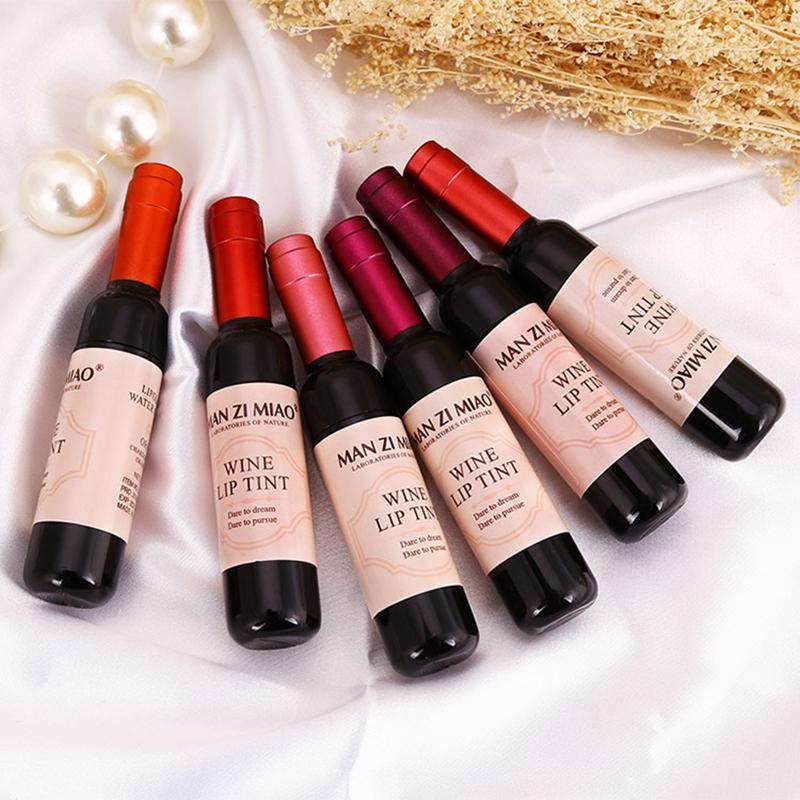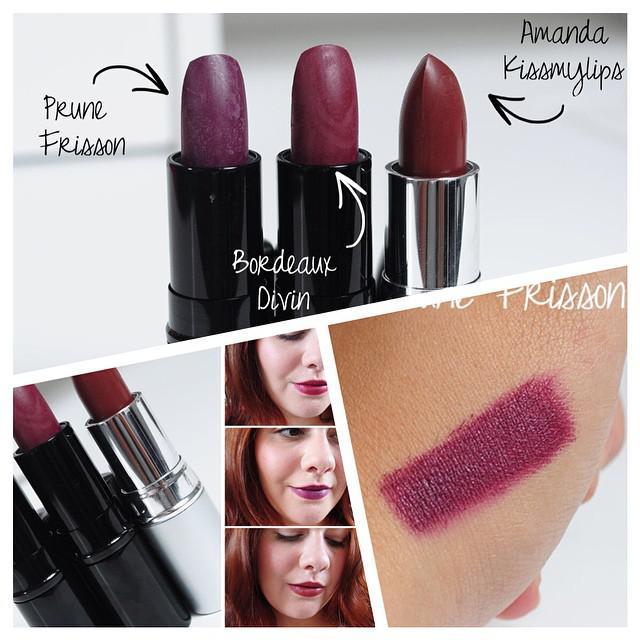The first image is the image on the left, the second image is the image on the right. For the images displayed, is the sentence "An image contains lip tints in little champagne bottles." factually correct? Answer yes or no. Yes. 